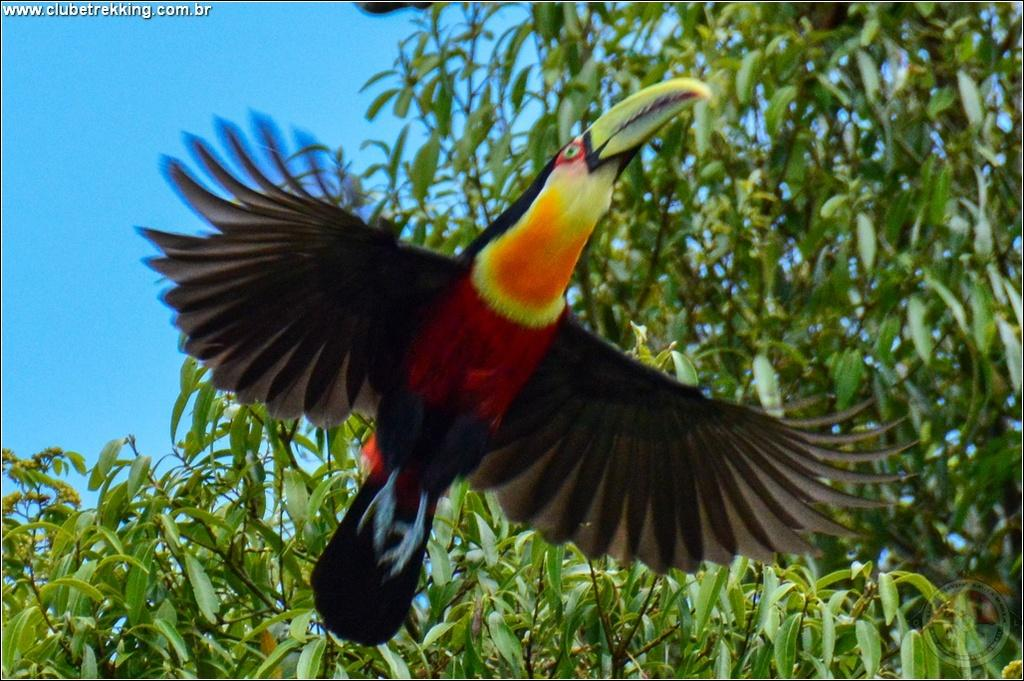What type of bird is in the image? There is a woodpecker in the image. What is the natural environment in the image? There are trees in the image. What can be seen above the trees in the image? The sky is visible in the image. What color is the rose on the woodpecker's knee in the image? There is no rose or knee present on the woodpecker in the image. 